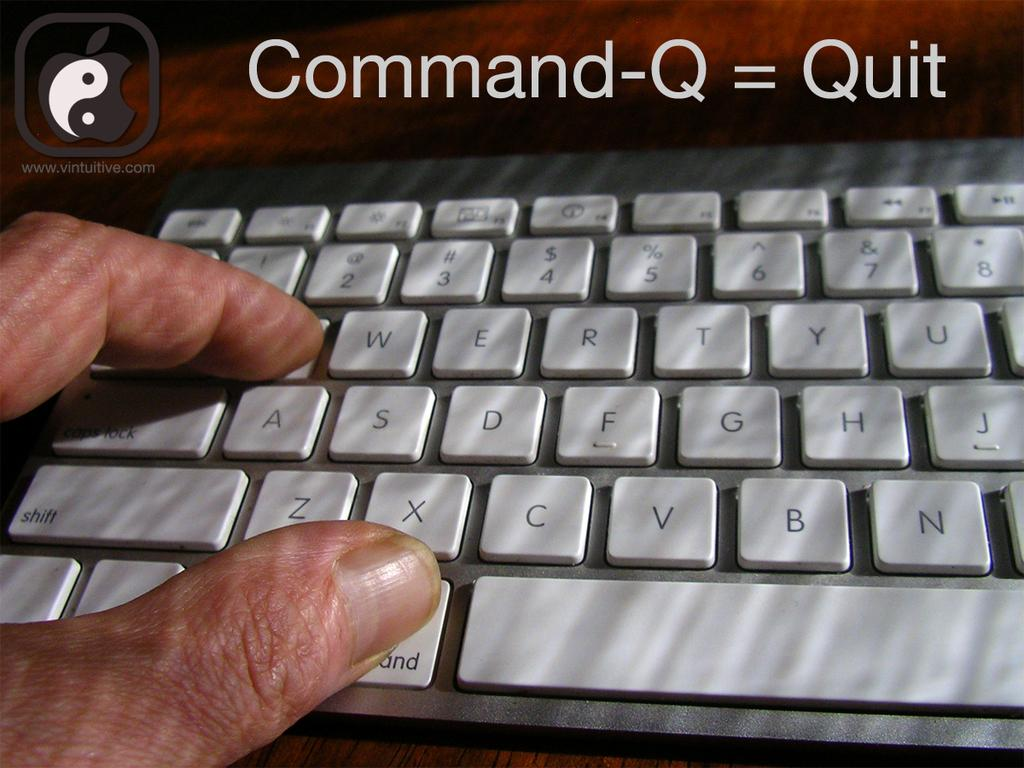Provide a one-sentence caption for the provided image. An apple keyboard is shown with instructions of how to use the quit function. 